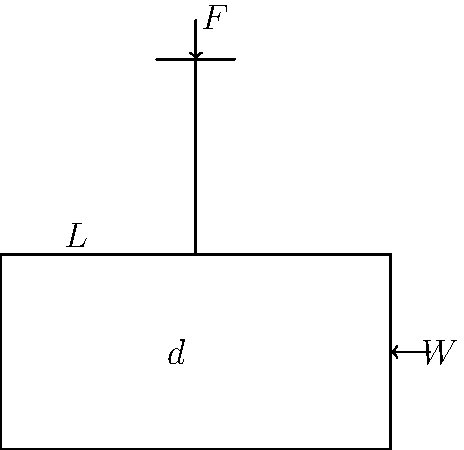A manual seed spreader for organic fertilizers requires a certain force to operate. The spreader has a total weight of 15 kg when fully loaded. If the handle is 1 meter long and the center of mass is 0.3 meters from the pivot point, what is the minimum force required to lift the spreader off the ground? To solve this problem, we'll use the principle of moments:

1. Identify the given information:
   - Weight of spreader (W) = 15 kg × 9.81 m/s² = 147.15 N
   - Length of handle (L) = 1 m
   - Distance of center of mass from pivot (d) = 0.3 m

2. Set up the moment equation:
   $F \times L = W \times d$

3. Substitute the known values:
   $F \times 1 = 147.15 \times 0.3$

4. Solve for F:
   $F = \frac{147.15 \times 0.3}{1} = 44.145$ N

5. Round to two decimal places:
   $F \approx 44.15$ N

Therefore, the minimum force required to lift the spreader off the ground is approximately 44.15 N.
Answer: 44.15 N 